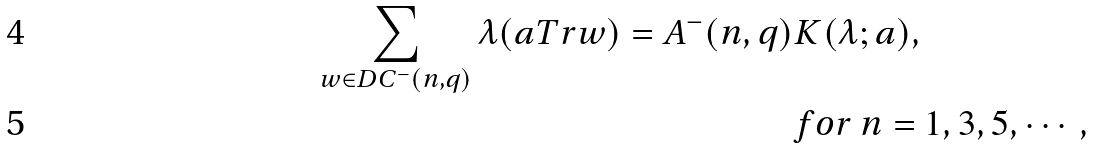Convert formula to latex. <formula><loc_0><loc_0><loc_500><loc_500>\sum _ { w \in D C ^ { - } ( n , q ) } \lambda ( a T r w ) = A ^ { - } ( n , q ) & K ( \lambda ; a ) , \\ & f o r \, n = 1 , 3 , 5 , \cdots ,</formula> 